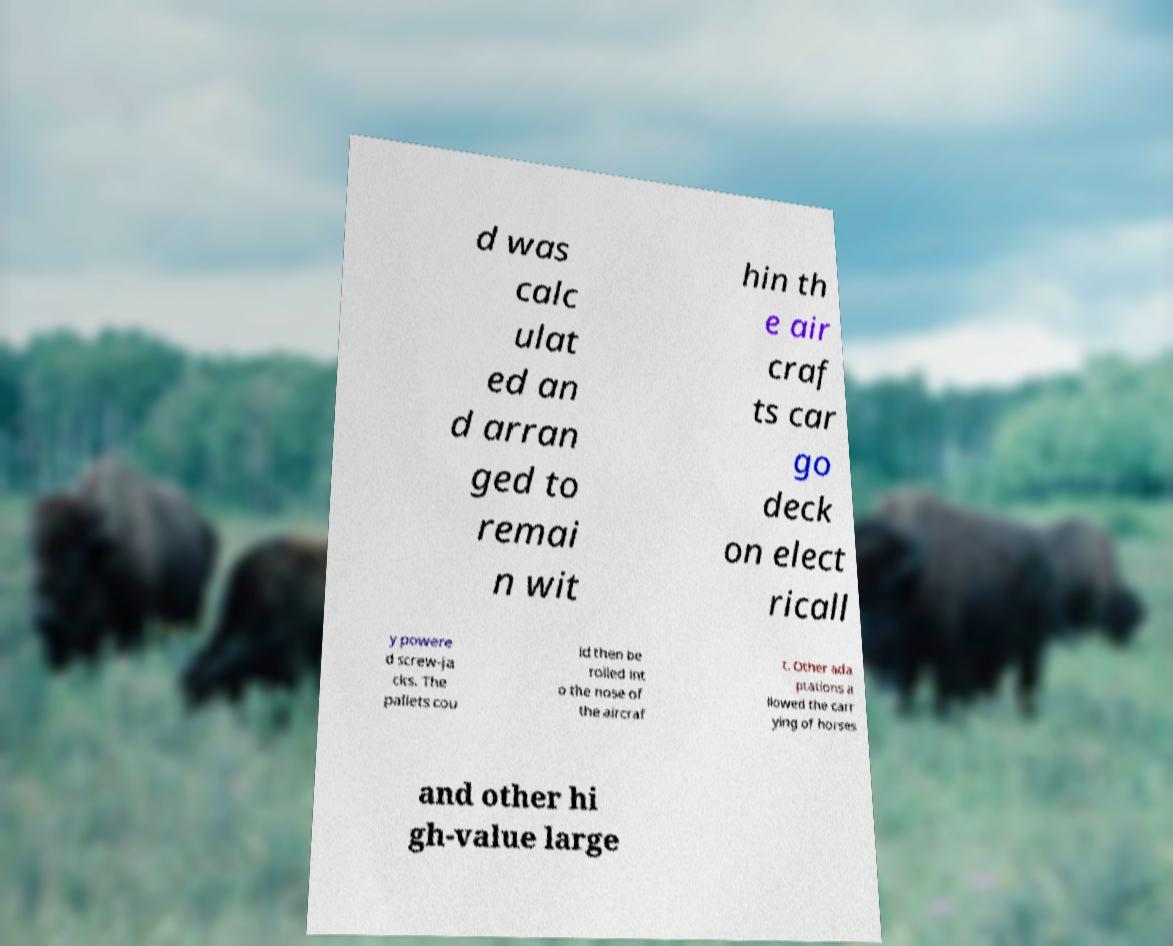Can you accurately transcribe the text from the provided image for me? d was calc ulat ed an d arran ged to remai n wit hin th e air craf ts car go deck on elect ricall y powere d screw-ja cks. The pallets cou ld then be rolled int o the nose of the aircraf t. Other ada ptations a llowed the carr ying of horses and other hi gh-value large 